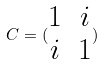Convert formula to latex. <formula><loc_0><loc_0><loc_500><loc_500>C = ( \begin{matrix} 1 & i \\ i & 1 \end{matrix} )</formula> 